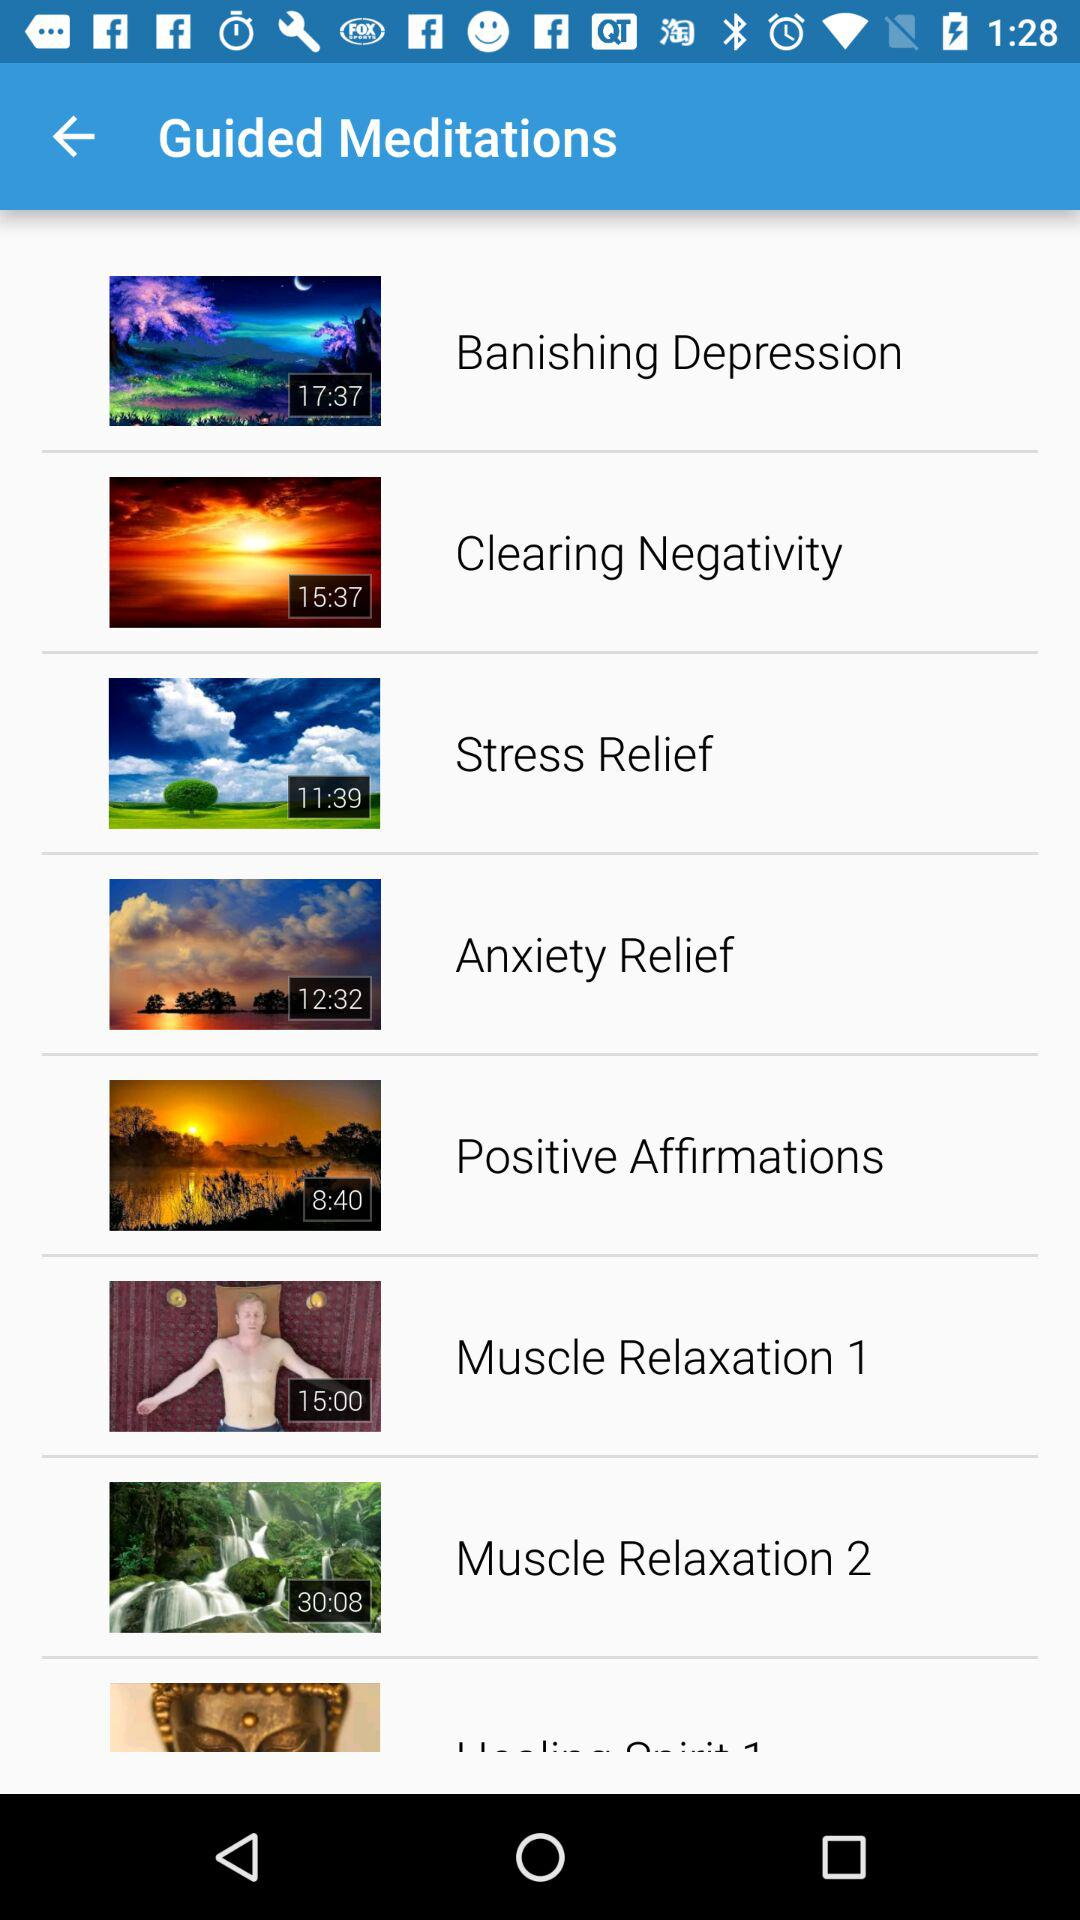What is the video length of "Muscle Relaxation 2"? The length of the video is 30:08. 